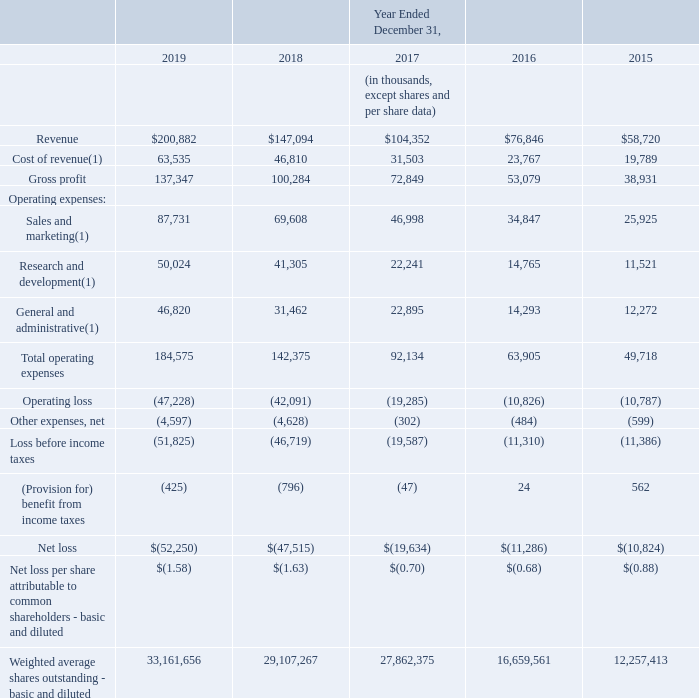Item 6. Selected Financial Data.
SELECTED CONSOLIDATED FINANCIAL DATA
The following selected historical financial data should be read in conjunction with Item 7, “Management’s Discussion and Analysis of Financial Condition and Results of Operations,” and our consolidated financial statements and the related notes appearing in Item 8, “Financial Statements and Supplementary Data,” of this Annual Report on Form 10-K to fully understand the factors that may affect the comparability of the information presented below.
The selected consolidated financial data in this section are not intended to replace the consolidated financial statements and are qualified in their entirety by the consolidated financial statements and related notes included elsewhere in this Annual Report on Form 10-K.
The following selected consolidated statements of operations data for the years ended December 31, 2019, 2018 and 2017, and the consolidated balance sheet data as of December 31, 2019 and 2018, have been derived from our audited consolidated financial statements included elsewhere in this Annual Report on Form 10-K. The consolidated statements of operations data for the years ended December 31, 2016 and 2015 and the consolidated balance sheet data as of December 31, 2017, 2016 and 2015 have been derived from our audited consolidated financial statements not included in this Annual Report on Form 10-K. The selected consolidated financial data for the year ended December 31, 2019 and as of December 31, 2019 reflects the adoption of ASU No. 2016-02, Leases (Topic 842). The selected consolidated financial data for the years ended December 31, 2019 and 2018 and as of December 31, 2019 and 2018 reflects the adoption of ASU No. 2014-09, Revenue from Contracts with Customers. See Notes 15 and 18 of the notes to consolidated financial statements for a summary of adjustments. The summary consolidated financial data for the years ended December 31, 2018, 2017, 2016 and 2015 and as of December 31, 2018, 2017, 2016 and 2015 does not reflect the adoption of ASU 2016-02. The summary consolidated financial data for the years ended December 31, 2017, 2016 and 2015 and as of December 31, 2017, 2016 and 2015 does not reflect the adoption of ASU 2014-09.
What was the revenue in 2019 and 2018?
Answer scale should be: thousand. 200,882, 147,094. What was the cost of revenue in 2019?
Answer scale should be: thousand. 63,535. What was the Gross profit in 2018?
Answer scale should be: thousand. 100,284. In which year was revenue less than 100,000 thousands? Locate and analyze revenue in row 4
answer: 2016, 2015. What is the average cost of revenue from 2015-2019?
Answer scale should be: thousand. (63,535 + 46,810 + 31,503 + 23,767 + 19,789) / 5
Answer: 37080.8. What is the change in the Gross Profit from 2018 to 2019?
Answer scale should be: thousand. 137,347 - 100,284
Answer: 37063. 